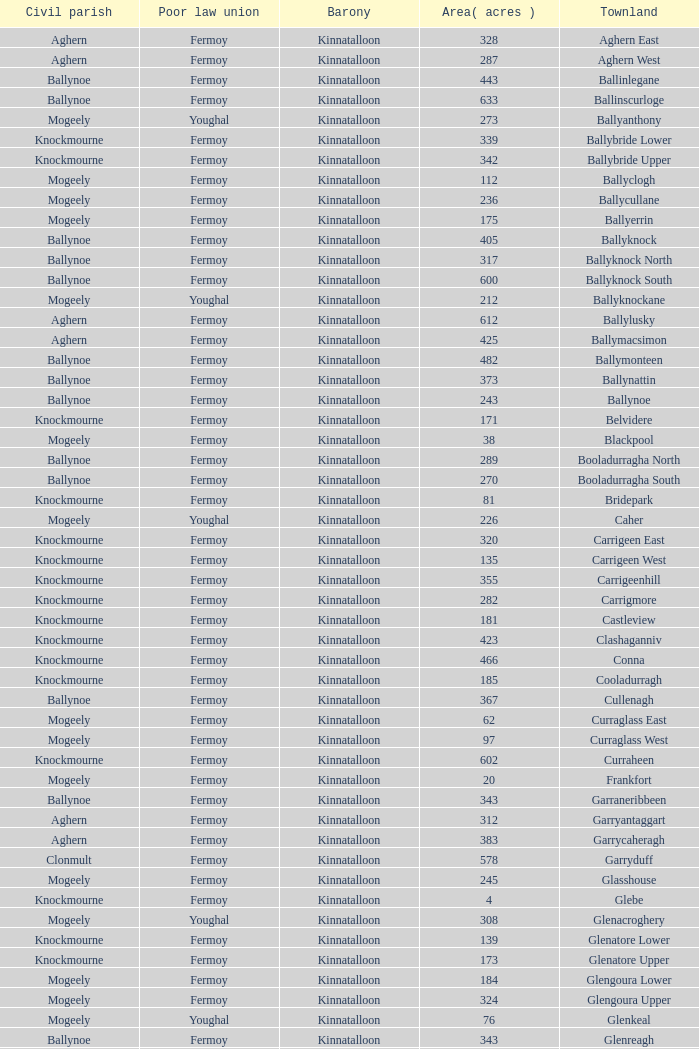Name the civil parish for garryduff Clonmult. 